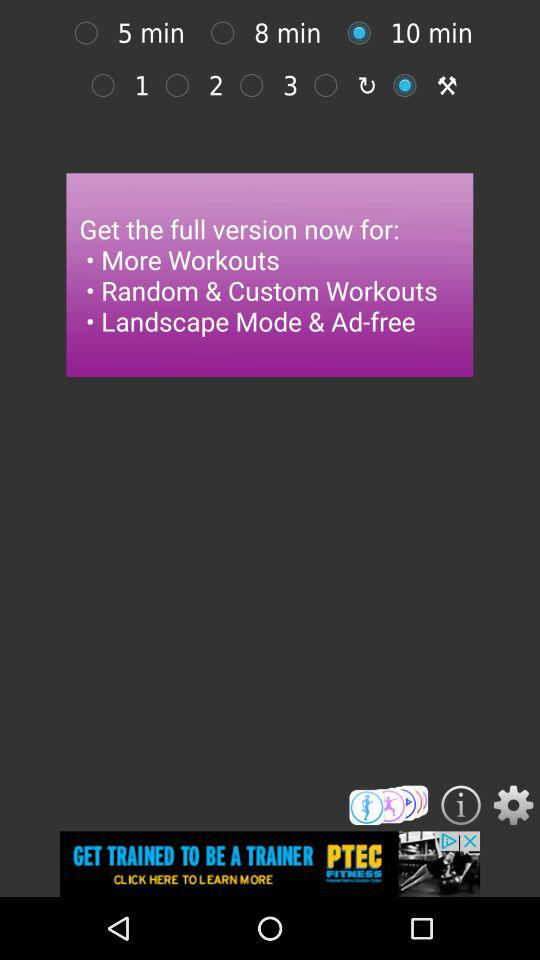Which option is selected? The selected options are "10 min" and "Tools". 